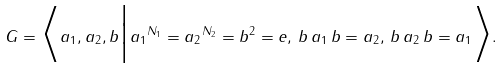<formula> <loc_0><loc_0><loc_500><loc_500>G = \Big \langle a _ { 1 } , a _ { 2 } , b \Big | { a _ { 1 } } ^ { N _ { 1 } } = { a _ { 2 } } ^ { N _ { 2 } } = b ^ { 2 } = e , \, b \, a _ { 1 } \, b = a _ { 2 } , \, b \, a _ { 2 } \, b = a _ { 1 } \Big \rangle .</formula> 